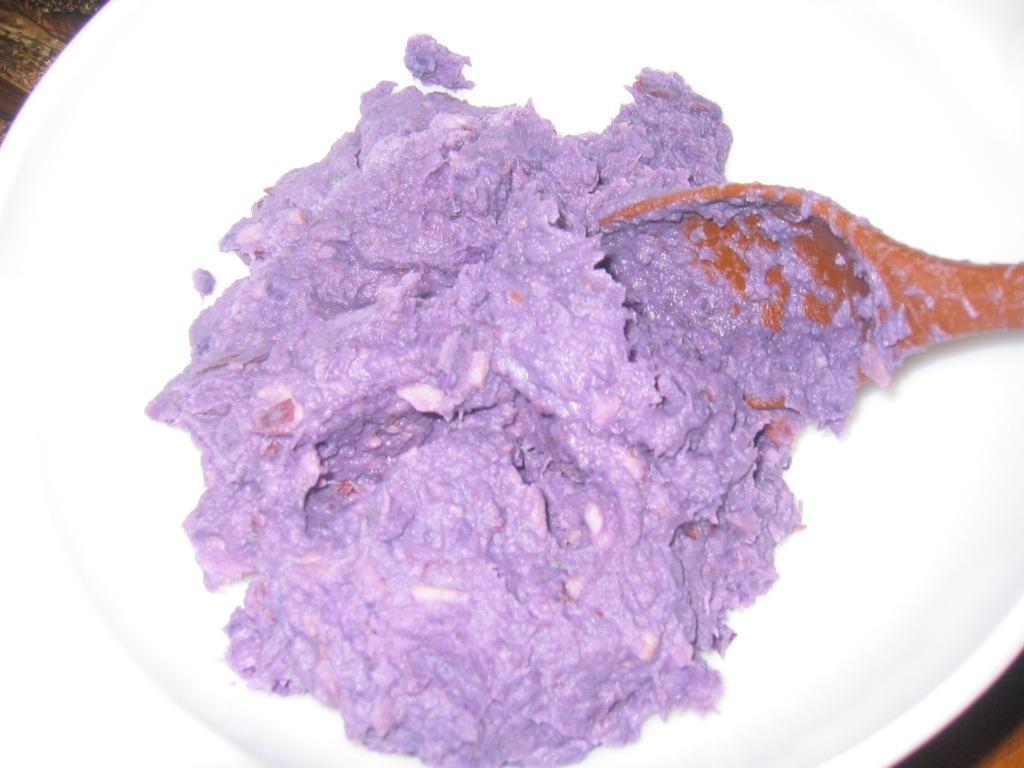Can you describe this image briefly? In this picture there is a plate in the center of the image, which contains taiyaki and a spoon in it. 